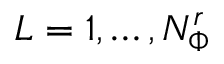Convert formula to latex. <formula><loc_0><loc_0><loc_500><loc_500>L = 1 , \dots , N _ { \Phi } ^ { r }</formula> 